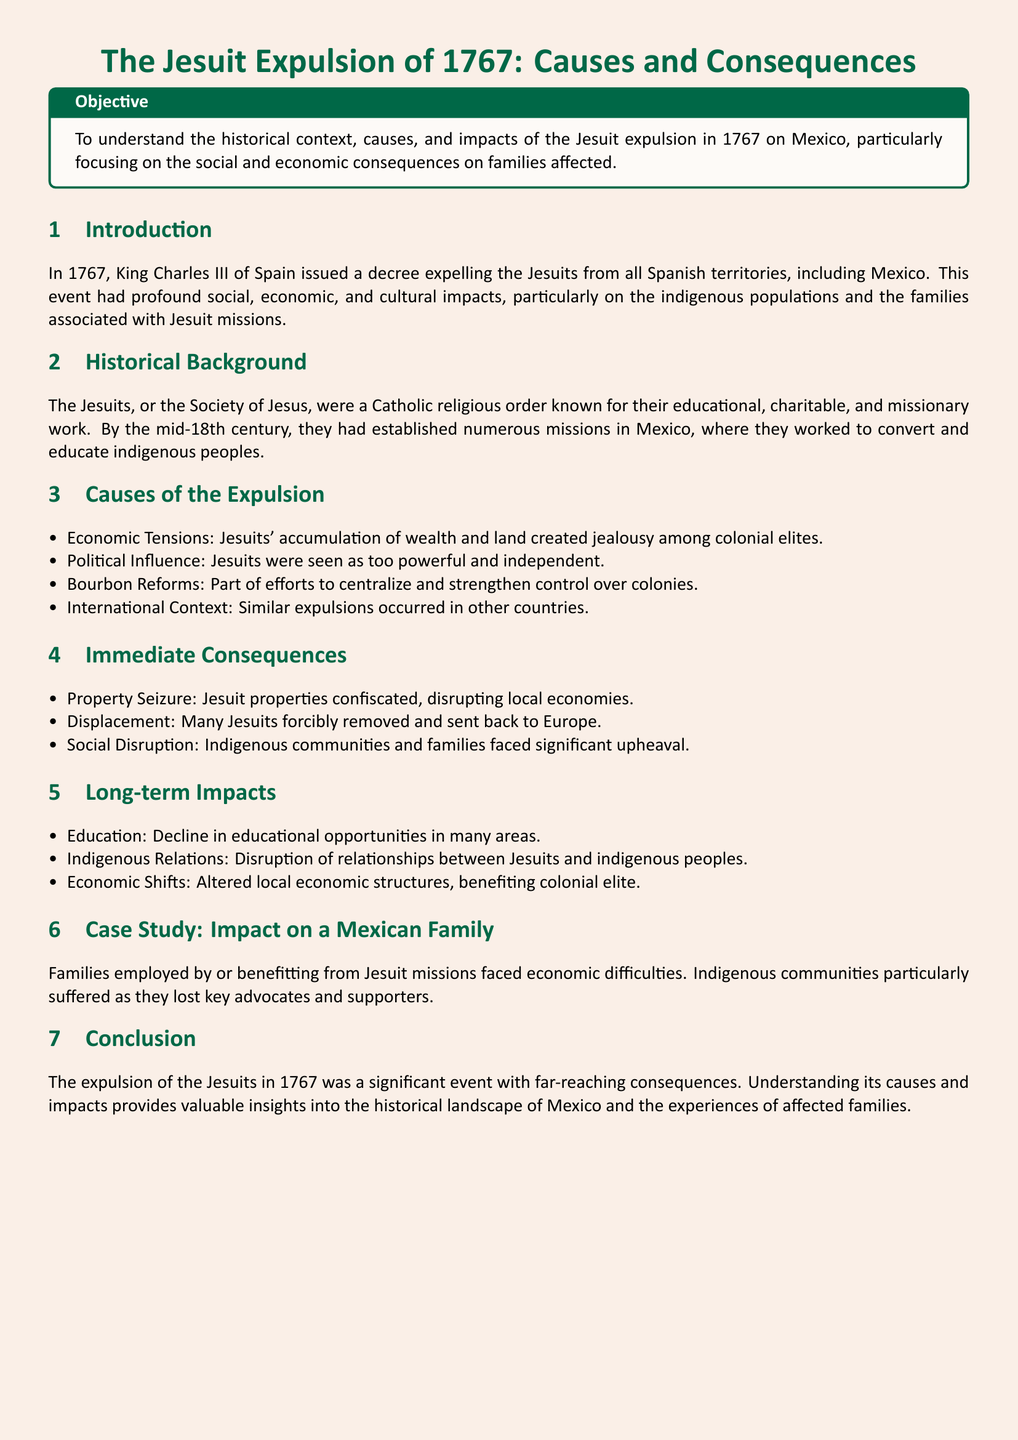What year did King Charles III expel the Jesuits? The year of the expulsion, as stated in the introduction, is 1767.
Answer: 1767 What was one of the economic consequences of the Jesuit expulsion? The document mentions property seizure as a consequence, which disrupted local economies.
Answer: Property Seizure Which social group particularly suffered from the Jesuit expulsion according to the case study? The case study specifies that indigenous communities faced significant difficulties due to the expulsion.
Answer: Indigenous communities What was a major cause linked to the Bourbon Reforms? The text indicates that the Bourbon Reforms aimed to centralize and strengthen control over colonies, leading to the Jesuit expulsion.
Answer: Centralization In what aspect did the Jesuits influence education before their expulsion? The document notes that Jesuits were known for their educational work, which declined after their expulsion.
Answer: Educational opportunities What type of document is this? The structure and content indicate that it is a lesson plan focusing on a historical event.
Answer: Lesson plan 